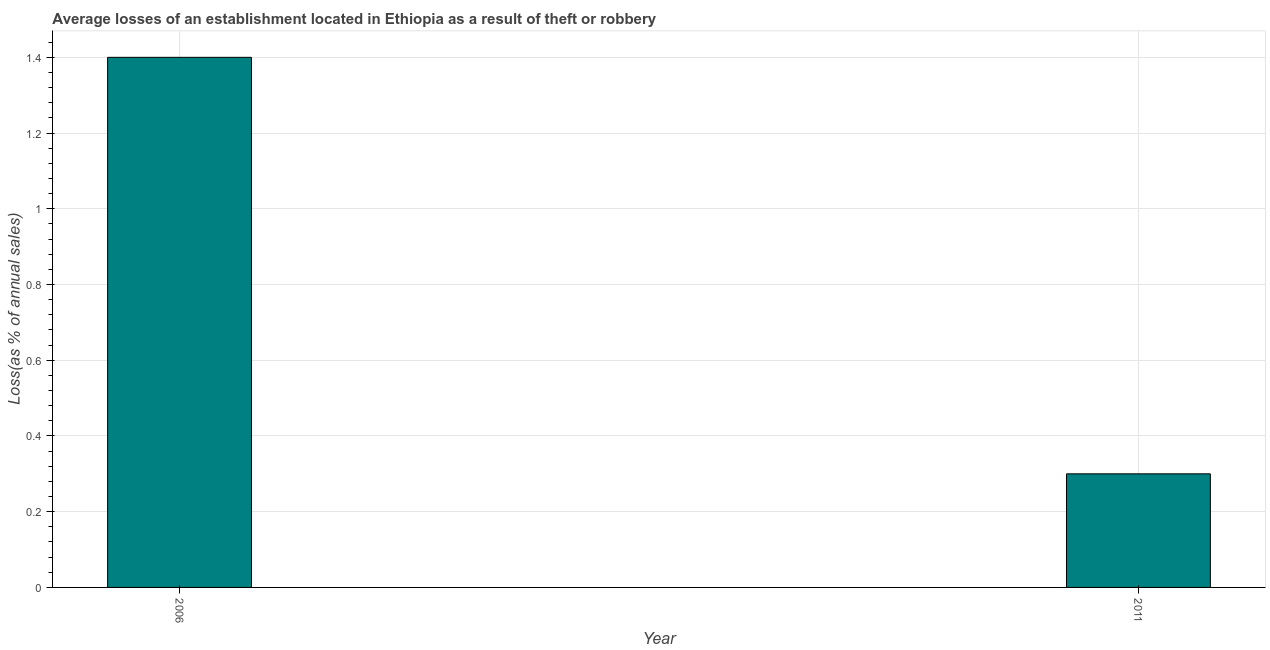Does the graph contain grids?
Give a very brief answer. Yes. What is the title of the graph?
Give a very brief answer. Average losses of an establishment located in Ethiopia as a result of theft or robbery. What is the label or title of the X-axis?
Your answer should be very brief. Year. What is the label or title of the Y-axis?
Your response must be concise. Loss(as % of annual sales). Across all years, what is the maximum losses due to theft?
Offer a terse response. 1.4. Across all years, what is the minimum losses due to theft?
Offer a very short reply. 0.3. In which year was the losses due to theft maximum?
Ensure brevity in your answer.  2006. In which year was the losses due to theft minimum?
Provide a short and direct response. 2011. What is the average losses due to theft per year?
Make the answer very short. 0.85. What is the median losses due to theft?
Give a very brief answer. 0.85. In how many years, is the losses due to theft greater than 1.28 %?
Give a very brief answer. 1. What is the ratio of the losses due to theft in 2006 to that in 2011?
Your response must be concise. 4.67. Is the losses due to theft in 2006 less than that in 2011?
Offer a very short reply. No. In how many years, is the losses due to theft greater than the average losses due to theft taken over all years?
Your response must be concise. 1. How many bars are there?
Keep it short and to the point. 2. Are all the bars in the graph horizontal?
Your answer should be compact. No. What is the difference between two consecutive major ticks on the Y-axis?
Keep it short and to the point. 0.2. What is the Loss(as % of annual sales) in 2011?
Provide a short and direct response. 0.3. What is the difference between the Loss(as % of annual sales) in 2006 and 2011?
Your answer should be very brief. 1.1. What is the ratio of the Loss(as % of annual sales) in 2006 to that in 2011?
Make the answer very short. 4.67. 